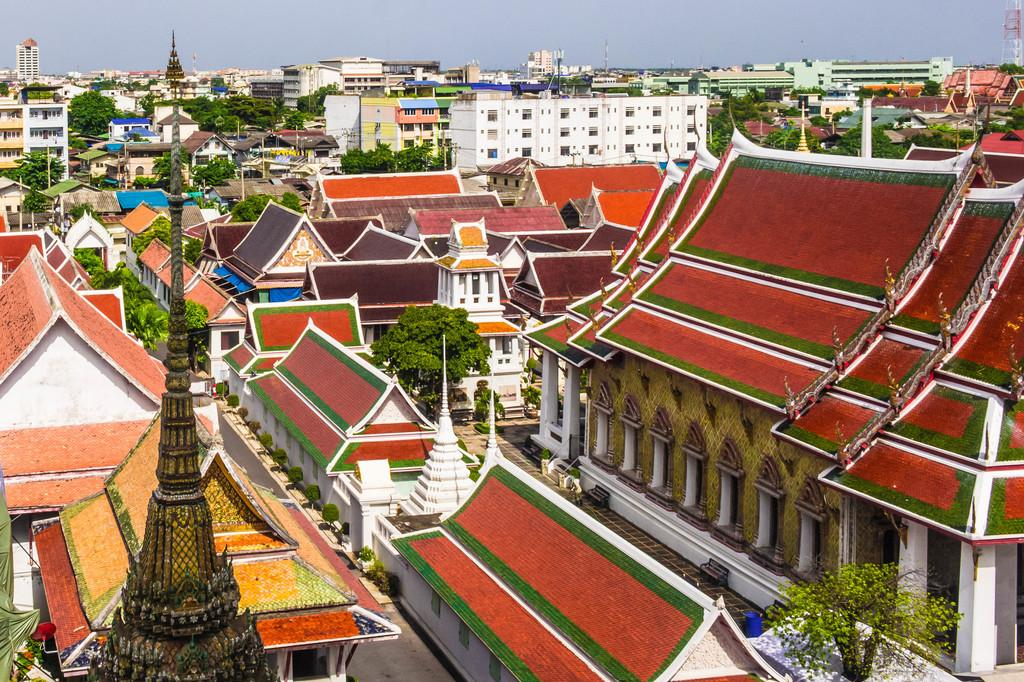What type of structures can be seen in the image? There are houses in the image. What else is present in the image besides the houses? There are poles and large trees in the image. Can you describe the placement of the trees in relation to the houses? The large trees are located between the houses. What type of whip can be seen hanging from the authority figure in the image? There is no authority figure or whip present in the image. 